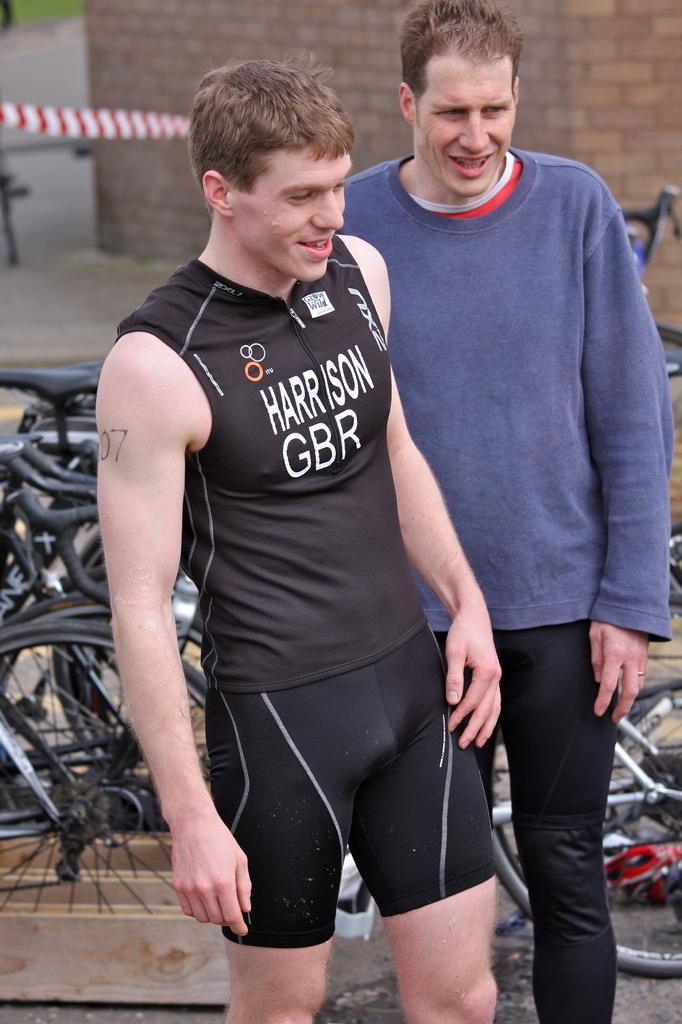<image>
Describe the image concisely. a person with the word Harrison on their shirt 